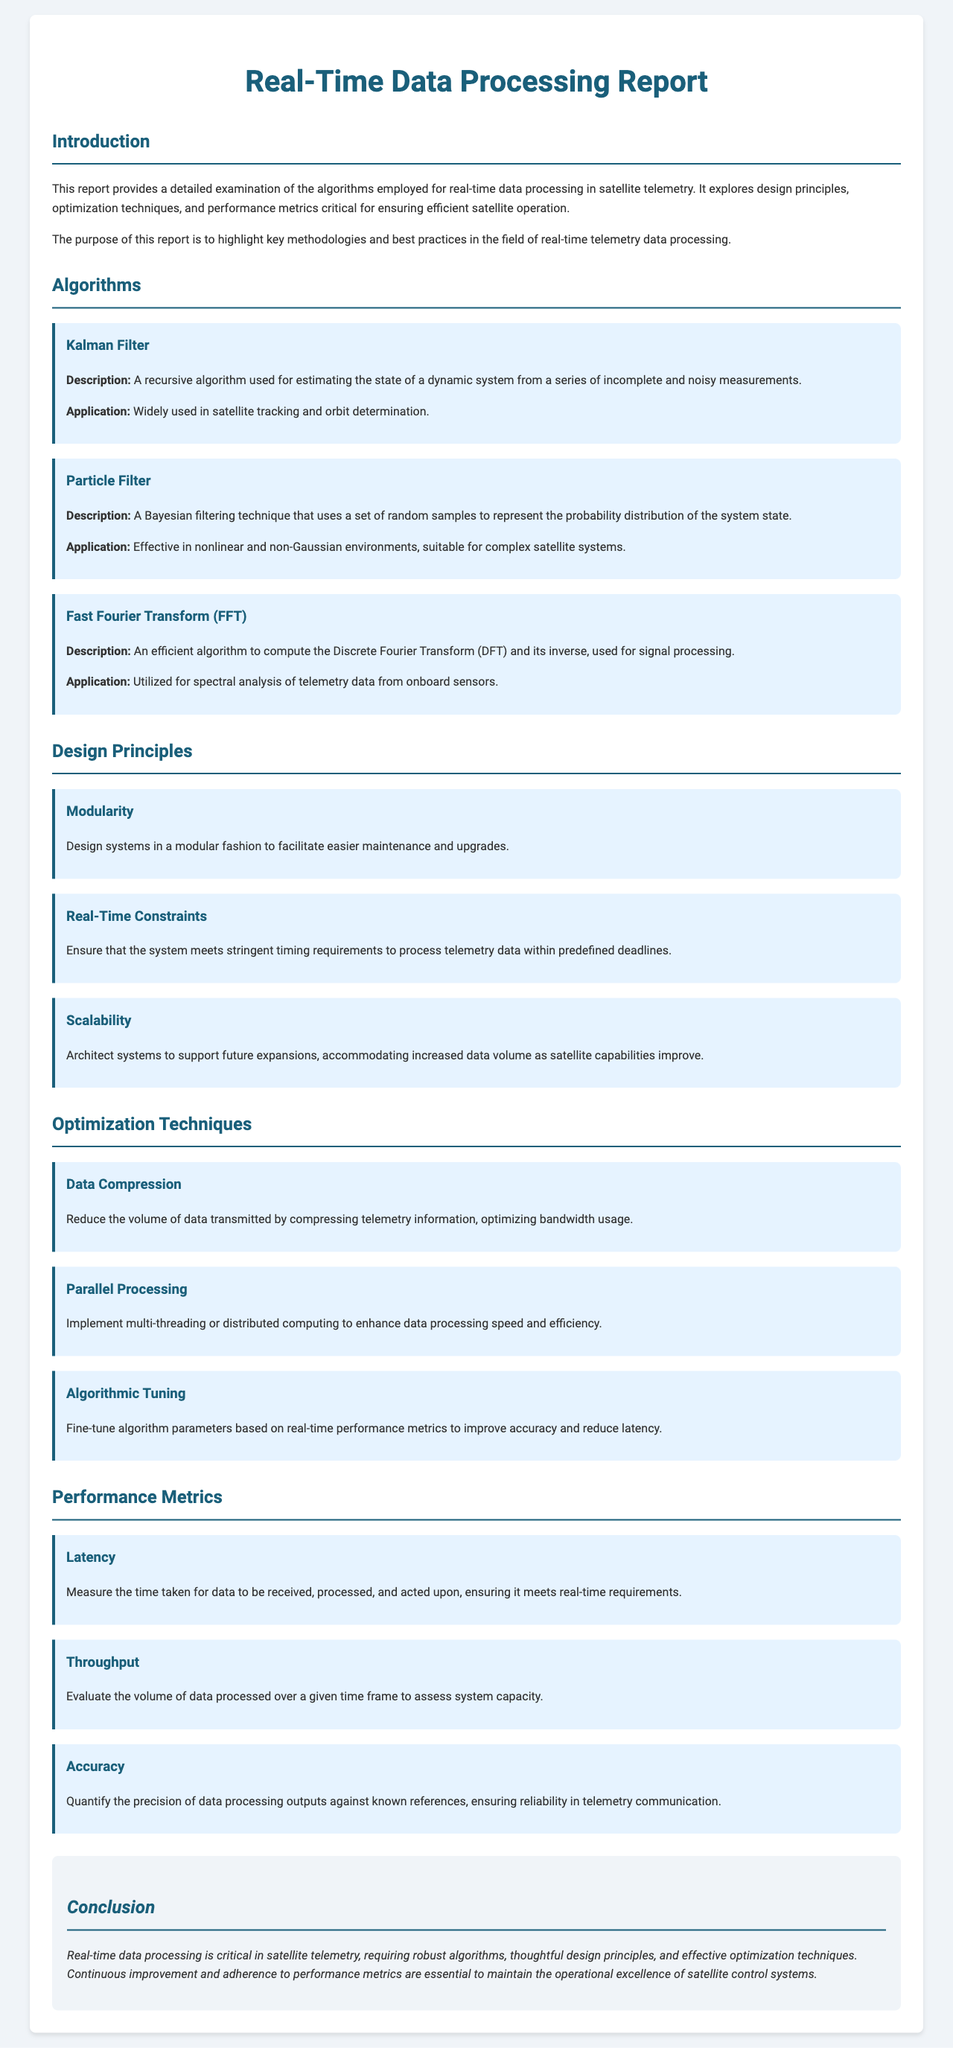What is the title of the report? The title of the report is prominently displayed at the top of the document.
Answer: Real-Time Data Processing Report Which algorithm is widely used in satellite tracking? The document lists specific algorithms with their applications, one of which is notable for satellite tracking.
Answer: Kalman Filter What is one design principle mentioned in the report? The report outlines several design principles, one of which can be identified in a distinct section.
Answer: Modularity How many optimization techniques are discussed? The report details a specific number of optimization techniques relevant to the subject.
Answer: Three What is the performance metric focused on processing speed? The report categorizes performance metrics, one of which relates directly to how fast data is handled.
Answer: Throughput What does the Fast Fourier Transform (FFT) compute? The application of the Fast Fourier Transform (FFT) is explained in the context of data processing tasks.
Answer: Discrete Fourier Transform What type of systems are suggested for accommodating future expansions? The document discusses design principles that include considerations for future system capabilities.
Answer: Scalable systems What is the emphasized importance of real-time data processing in satellites? The conclusion highlights a critical aspect of satellite operations related to data processing.
Answer: Operational excellence 